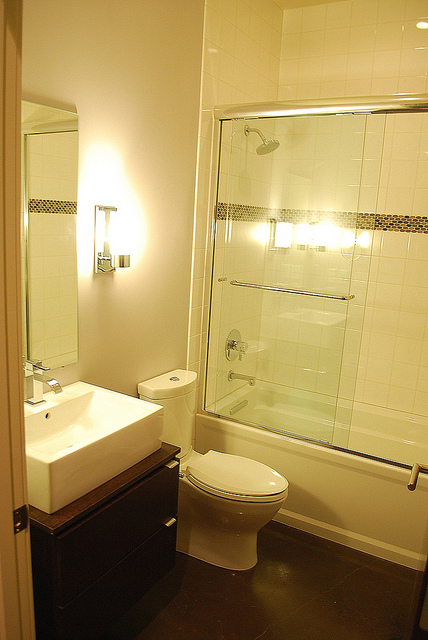<image>What color is the shower curtain? There is no shower curtain in the image. What color is the shower curtain? There is no shower curtain in the image. 